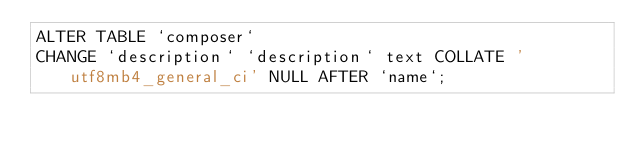Convert code to text. <code><loc_0><loc_0><loc_500><loc_500><_SQL_>ALTER TABLE `composer`
CHANGE `description` `description` text COLLATE 'utf8mb4_general_ci' NULL AFTER `name`;
</code> 